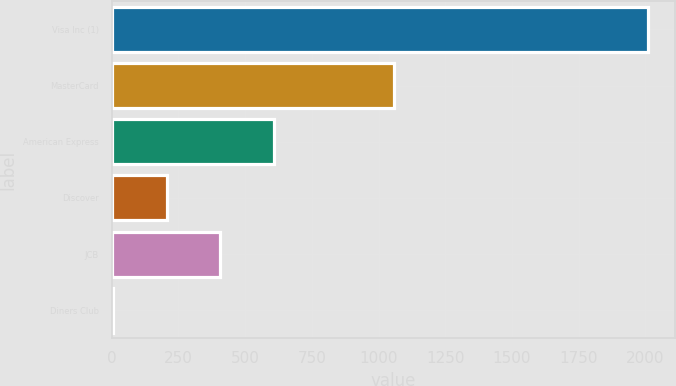Convert chart to OTSL. <chart><loc_0><loc_0><loc_500><loc_500><bar_chart><fcel>Visa Inc (1)<fcel>MasterCard<fcel>American Express<fcel>Discover<fcel>JCB<fcel>Diners Club<nl><fcel>2011<fcel>1059<fcel>607.5<fcel>206.5<fcel>407<fcel>6<nl></chart> 